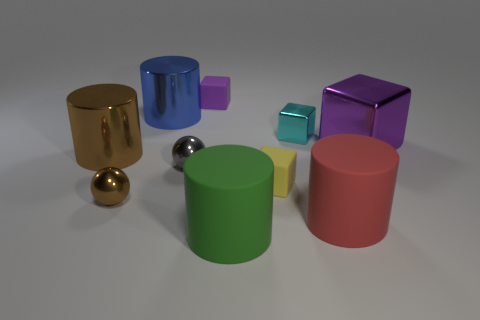The block that is made of the same material as the small cyan object is what color?
Your answer should be very brief. Purple. There is a tiny rubber block behind the large brown cylinder; are there any blue things behind it?
Offer a terse response. No. What number of other objects are the same shape as the tiny cyan metallic object?
Make the answer very short. 3. Does the big rubber object that is left of the red object have the same shape as the brown object that is behind the gray metal ball?
Your answer should be very brief. Yes. There is a tiny ball in front of the tiny ball that is to the right of the small brown thing; what number of tiny brown spheres are in front of it?
Provide a succinct answer. 0. What color is the big cube?
Your answer should be compact. Purple. What number of other objects are there of the same size as the brown ball?
Your response must be concise. 4. There is a tiny cyan thing that is the same shape as the tiny yellow matte object; what material is it?
Make the answer very short. Metal. The cube in front of the sphere behind the ball left of the blue thing is made of what material?
Give a very brief answer. Rubber. What is the size of the purple thing that is the same material as the big red cylinder?
Provide a short and direct response. Small. 